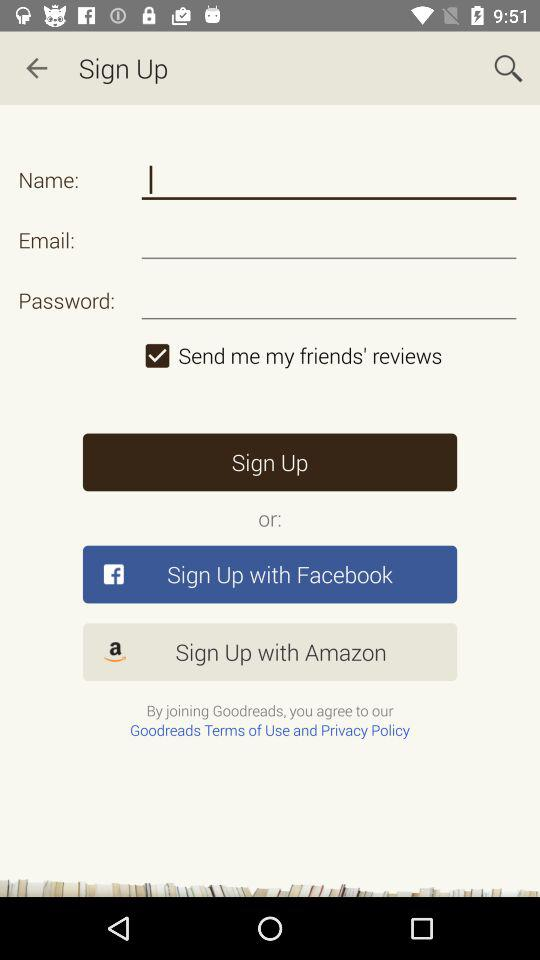What are the options for sign up? The options for sign up are "Email", "Facebook" and "Amazon". 